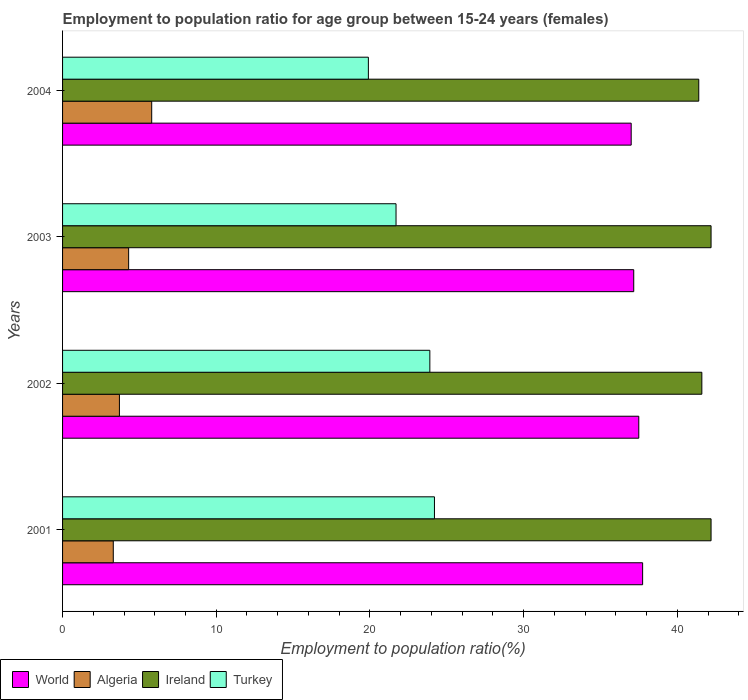How many different coloured bars are there?
Ensure brevity in your answer.  4. Are the number of bars per tick equal to the number of legend labels?
Ensure brevity in your answer.  Yes. How many bars are there on the 2nd tick from the top?
Make the answer very short. 4. What is the employment to population ratio in Ireland in 2004?
Make the answer very short. 41.4. Across all years, what is the maximum employment to population ratio in World?
Provide a short and direct response. 37.75. Across all years, what is the minimum employment to population ratio in World?
Make the answer very short. 37. What is the total employment to population ratio in Ireland in the graph?
Offer a very short reply. 167.4. What is the difference between the employment to population ratio in Turkey in 2002 and that in 2003?
Keep it short and to the point. 2.2. What is the difference between the employment to population ratio in Algeria in 2004 and the employment to population ratio in Ireland in 2002?
Your answer should be very brief. -35.8. What is the average employment to population ratio in Turkey per year?
Provide a short and direct response. 22.43. In the year 2003, what is the difference between the employment to population ratio in World and employment to population ratio in Ireland?
Make the answer very short. -5.03. What is the ratio of the employment to population ratio in Algeria in 2001 to that in 2002?
Your answer should be compact. 0.89. Is the employment to population ratio in Algeria in 2001 less than that in 2004?
Provide a short and direct response. Yes. What is the difference between the highest and the second highest employment to population ratio in World?
Your response must be concise. 0.25. What is the difference between the highest and the lowest employment to population ratio in Ireland?
Your answer should be compact. 0.8. In how many years, is the employment to population ratio in Ireland greater than the average employment to population ratio in Ireland taken over all years?
Make the answer very short. 2. What does the 4th bar from the bottom in 2003 represents?
Give a very brief answer. Turkey. How many bars are there?
Give a very brief answer. 16. What is the difference between two consecutive major ticks on the X-axis?
Provide a succinct answer. 10. Are the values on the major ticks of X-axis written in scientific E-notation?
Ensure brevity in your answer.  No. Does the graph contain any zero values?
Make the answer very short. No. Where does the legend appear in the graph?
Offer a terse response. Bottom left. How are the legend labels stacked?
Your response must be concise. Horizontal. What is the title of the graph?
Offer a very short reply. Employment to population ratio for age group between 15-24 years (females). What is the label or title of the X-axis?
Ensure brevity in your answer.  Employment to population ratio(%). What is the Employment to population ratio(%) in World in 2001?
Offer a terse response. 37.75. What is the Employment to population ratio(%) of Algeria in 2001?
Make the answer very short. 3.3. What is the Employment to population ratio(%) of Ireland in 2001?
Your answer should be compact. 42.2. What is the Employment to population ratio(%) in Turkey in 2001?
Ensure brevity in your answer.  24.2. What is the Employment to population ratio(%) in World in 2002?
Keep it short and to the point. 37.5. What is the Employment to population ratio(%) of Algeria in 2002?
Provide a succinct answer. 3.7. What is the Employment to population ratio(%) in Ireland in 2002?
Give a very brief answer. 41.6. What is the Employment to population ratio(%) in Turkey in 2002?
Ensure brevity in your answer.  23.9. What is the Employment to population ratio(%) in World in 2003?
Offer a very short reply. 37.17. What is the Employment to population ratio(%) of Algeria in 2003?
Your answer should be very brief. 4.3. What is the Employment to population ratio(%) of Ireland in 2003?
Offer a terse response. 42.2. What is the Employment to population ratio(%) of Turkey in 2003?
Offer a terse response. 21.7. What is the Employment to population ratio(%) in World in 2004?
Your response must be concise. 37. What is the Employment to population ratio(%) of Algeria in 2004?
Your answer should be compact. 5.8. What is the Employment to population ratio(%) in Ireland in 2004?
Give a very brief answer. 41.4. What is the Employment to population ratio(%) of Turkey in 2004?
Ensure brevity in your answer.  19.9. Across all years, what is the maximum Employment to population ratio(%) in World?
Keep it short and to the point. 37.75. Across all years, what is the maximum Employment to population ratio(%) in Algeria?
Offer a terse response. 5.8. Across all years, what is the maximum Employment to population ratio(%) of Ireland?
Your response must be concise. 42.2. Across all years, what is the maximum Employment to population ratio(%) of Turkey?
Your answer should be compact. 24.2. Across all years, what is the minimum Employment to population ratio(%) of World?
Ensure brevity in your answer.  37. Across all years, what is the minimum Employment to population ratio(%) in Algeria?
Offer a very short reply. 3.3. Across all years, what is the minimum Employment to population ratio(%) of Ireland?
Make the answer very short. 41.4. Across all years, what is the minimum Employment to population ratio(%) of Turkey?
Provide a short and direct response. 19.9. What is the total Employment to population ratio(%) of World in the graph?
Provide a succinct answer. 149.41. What is the total Employment to population ratio(%) of Ireland in the graph?
Provide a succinct answer. 167.4. What is the total Employment to population ratio(%) of Turkey in the graph?
Provide a short and direct response. 89.7. What is the difference between the Employment to population ratio(%) of World in 2001 and that in 2002?
Your answer should be very brief. 0.25. What is the difference between the Employment to population ratio(%) in Algeria in 2001 and that in 2002?
Ensure brevity in your answer.  -0.4. What is the difference between the Employment to population ratio(%) of Turkey in 2001 and that in 2002?
Give a very brief answer. 0.3. What is the difference between the Employment to population ratio(%) of World in 2001 and that in 2003?
Provide a succinct answer. 0.58. What is the difference between the Employment to population ratio(%) of World in 2001 and that in 2004?
Provide a short and direct response. 0.74. What is the difference between the Employment to population ratio(%) in Algeria in 2001 and that in 2004?
Offer a very short reply. -2.5. What is the difference between the Employment to population ratio(%) of Ireland in 2001 and that in 2004?
Your response must be concise. 0.8. What is the difference between the Employment to population ratio(%) in World in 2002 and that in 2003?
Offer a very short reply. 0.33. What is the difference between the Employment to population ratio(%) in Algeria in 2002 and that in 2003?
Your answer should be compact. -0.6. What is the difference between the Employment to population ratio(%) in Ireland in 2002 and that in 2003?
Offer a terse response. -0.6. What is the difference between the Employment to population ratio(%) of Turkey in 2002 and that in 2003?
Offer a terse response. 2.2. What is the difference between the Employment to population ratio(%) in World in 2002 and that in 2004?
Make the answer very short. 0.49. What is the difference between the Employment to population ratio(%) of Algeria in 2002 and that in 2004?
Your answer should be compact. -2.1. What is the difference between the Employment to population ratio(%) of Ireland in 2002 and that in 2004?
Provide a short and direct response. 0.2. What is the difference between the Employment to population ratio(%) of Turkey in 2002 and that in 2004?
Your answer should be very brief. 4. What is the difference between the Employment to population ratio(%) in World in 2003 and that in 2004?
Your response must be concise. 0.17. What is the difference between the Employment to population ratio(%) of World in 2001 and the Employment to population ratio(%) of Algeria in 2002?
Offer a terse response. 34.05. What is the difference between the Employment to population ratio(%) of World in 2001 and the Employment to population ratio(%) of Ireland in 2002?
Your response must be concise. -3.85. What is the difference between the Employment to population ratio(%) of World in 2001 and the Employment to population ratio(%) of Turkey in 2002?
Offer a very short reply. 13.85. What is the difference between the Employment to population ratio(%) of Algeria in 2001 and the Employment to population ratio(%) of Ireland in 2002?
Make the answer very short. -38.3. What is the difference between the Employment to population ratio(%) in Algeria in 2001 and the Employment to population ratio(%) in Turkey in 2002?
Ensure brevity in your answer.  -20.6. What is the difference between the Employment to population ratio(%) of Ireland in 2001 and the Employment to population ratio(%) of Turkey in 2002?
Your answer should be compact. 18.3. What is the difference between the Employment to population ratio(%) in World in 2001 and the Employment to population ratio(%) in Algeria in 2003?
Your answer should be very brief. 33.45. What is the difference between the Employment to population ratio(%) in World in 2001 and the Employment to population ratio(%) in Ireland in 2003?
Your response must be concise. -4.45. What is the difference between the Employment to population ratio(%) in World in 2001 and the Employment to population ratio(%) in Turkey in 2003?
Make the answer very short. 16.05. What is the difference between the Employment to population ratio(%) in Algeria in 2001 and the Employment to population ratio(%) in Ireland in 2003?
Keep it short and to the point. -38.9. What is the difference between the Employment to population ratio(%) of Algeria in 2001 and the Employment to population ratio(%) of Turkey in 2003?
Your answer should be compact. -18.4. What is the difference between the Employment to population ratio(%) of World in 2001 and the Employment to population ratio(%) of Algeria in 2004?
Offer a very short reply. 31.95. What is the difference between the Employment to population ratio(%) of World in 2001 and the Employment to population ratio(%) of Ireland in 2004?
Provide a short and direct response. -3.65. What is the difference between the Employment to population ratio(%) in World in 2001 and the Employment to population ratio(%) in Turkey in 2004?
Your response must be concise. 17.85. What is the difference between the Employment to population ratio(%) in Algeria in 2001 and the Employment to population ratio(%) in Ireland in 2004?
Your response must be concise. -38.1. What is the difference between the Employment to population ratio(%) in Algeria in 2001 and the Employment to population ratio(%) in Turkey in 2004?
Your answer should be compact. -16.6. What is the difference between the Employment to population ratio(%) in Ireland in 2001 and the Employment to population ratio(%) in Turkey in 2004?
Offer a terse response. 22.3. What is the difference between the Employment to population ratio(%) in World in 2002 and the Employment to population ratio(%) in Algeria in 2003?
Provide a short and direct response. 33.2. What is the difference between the Employment to population ratio(%) in World in 2002 and the Employment to population ratio(%) in Ireland in 2003?
Ensure brevity in your answer.  -4.7. What is the difference between the Employment to population ratio(%) in World in 2002 and the Employment to population ratio(%) in Turkey in 2003?
Your answer should be compact. 15.8. What is the difference between the Employment to population ratio(%) in Algeria in 2002 and the Employment to population ratio(%) in Ireland in 2003?
Offer a very short reply. -38.5. What is the difference between the Employment to population ratio(%) in Ireland in 2002 and the Employment to population ratio(%) in Turkey in 2003?
Provide a succinct answer. 19.9. What is the difference between the Employment to population ratio(%) of World in 2002 and the Employment to population ratio(%) of Algeria in 2004?
Provide a short and direct response. 31.7. What is the difference between the Employment to population ratio(%) in World in 2002 and the Employment to population ratio(%) in Ireland in 2004?
Your response must be concise. -3.9. What is the difference between the Employment to population ratio(%) of World in 2002 and the Employment to population ratio(%) of Turkey in 2004?
Offer a terse response. 17.6. What is the difference between the Employment to population ratio(%) in Algeria in 2002 and the Employment to population ratio(%) in Ireland in 2004?
Make the answer very short. -37.7. What is the difference between the Employment to population ratio(%) of Algeria in 2002 and the Employment to population ratio(%) of Turkey in 2004?
Offer a very short reply. -16.2. What is the difference between the Employment to population ratio(%) in Ireland in 2002 and the Employment to population ratio(%) in Turkey in 2004?
Your answer should be very brief. 21.7. What is the difference between the Employment to population ratio(%) of World in 2003 and the Employment to population ratio(%) of Algeria in 2004?
Make the answer very short. 31.37. What is the difference between the Employment to population ratio(%) in World in 2003 and the Employment to population ratio(%) in Ireland in 2004?
Provide a short and direct response. -4.23. What is the difference between the Employment to population ratio(%) of World in 2003 and the Employment to population ratio(%) of Turkey in 2004?
Provide a succinct answer. 17.27. What is the difference between the Employment to population ratio(%) in Algeria in 2003 and the Employment to population ratio(%) in Ireland in 2004?
Ensure brevity in your answer.  -37.1. What is the difference between the Employment to population ratio(%) of Algeria in 2003 and the Employment to population ratio(%) of Turkey in 2004?
Your answer should be compact. -15.6. What is the difference between the Employment to population ratio(%) in Ireland in 2003 and the Employment to population ratio(%) in Turkey in 2004?
Your response must be concise. 22.3. What is the average Employment to population ratio(%) in World per year?
Provide a succinct answer. 37.35. What is the average Employment to population ratio(%) of Algeria per year?
Your answer should be very brief. 4.28. What is the average Employment to population ratio(%) in Ireland per year?
Provide a short and direct response. 41.85. What is the average Employment to population ratio(%) of Turkey per year?
Ensure brevity in your answer.  22.43. In the year 2001, what is the difference between the Employment to population ratio(%) of World and Employment to population ratio(%) of Algeria?
Give a very brief answer. 34.45. In the year 2001, what is the difference between the Employment to population ratio(%) in World and Employment to population ratio(%) in Ireland?
Give a very brief answer. -4.45. In the year 2001, what is the difference between the Employment to population ratio(%) in World and Employment to population ratio(%) in Turkey?
Give a very brief answer. 13.55. In the year 2001, what is the difference between the Employment to population ratio(%) of Algeria and Employment to population ratio(%) of Ireland?
Give a very brief answer. -38.9. In the year 2001, what is the difference between the Employment to population ratio(%) of Algeria and Employment to population ratio(%) of Turkey?
Provide a succinct answer. -20.9. In the year 2001, what is the difference between the Employment to population ratio(%) of Ireland and Employment to population ratio(%) of Turkey?
Provide a succinct answer. 18. In the year 2002, what is the difference between the Employment to population ratio(%) in World and Employment to population ratio(%) in Algeria?
Offer a very short reply. 33.8. In the year 2002, what is the difference between the Employment to population ratio(%) in World and Employment to population ratio(%) in Ireland?
Your answer should be very brief. -4.1. In the year 2002, what is the difference between the Employment to population ratio(%) of World and Employment to population ratio(%) of Turkey?
Provide a short and direct response. 13.6. In the year 2002, what is the difference between the Employment to population ratio(%) in Algeria and Employment to population ratio(%) in Ireland?
Ensure brevity in your answer.  -37.9. In the year 2002, what is the difference between the Employment to population ratio(%) in Algeria and Employment to population ratio(%) in Turkey?
Give a very brief answer. -20.2. In the year 2002, what is the difference between the Employment to population ratio(%) of Ireland and Employment to population ratio(%) of Turkey?
Keep it short and to the point. 17.7. In the year 2003, what is the difference between the Employment to population ratio(%) in World and Employment to population ratio(%) in Algeria?
Give a very brief answer. 32.87. In the year 2003, what is the difference between the Employment to population ratio(%) in World and Employment to population ratio(%) in Ireland?
Offer a terse response. -5.03. In the year 2003, what is the difference between the Employment to population ratio(%) in World and Employment to population ratio(%) in Turkey?
Offer a very short reply. 15.47. In the year 2003, what is the difference between the Employment to population ratio(%) of Algeria and Employment to population ratio(%) of Ireland?
Offer a very short reply. -37.9. In the year 2003, what is the difference between the Employment to population ratio(%) in Algeria and Employment to population ratio(%) in Turkey?
Keep it short and to the point. -17.4. In the year 2004, what is the difference between the Employment to population ratio(%) of World and Employment to population ratio(%) of Algeria?
Keep it short and to the point. 31.2. In the year 2004, what is the difference between the Employment to population ratio(%) in World and Employment to population ratio(%) in Ireland?
Keep it short and to the point. -4.4. In the year 2004, what is the difference between the Employment to population ratio(%) in World and Employment to population ratio(%) in Turkey?
Provide a succinct answer. 17.1. In the year 2004, what is the difference between the Employment to population ratio(%) in Algeria and Employment to population ratio(%) in Ireland?
Your answer should be very brief. -35.6. In the year 2004, what is the difference between the Employment to population ratio(%) in Algeria and Employment to population ratio(%) in Turkey?
Your answer should be very brief. -14.1. What is the ratio of the Employment to population ratio(%) in World in 2001 to that in 2002?
Keep it short and to the point. 1.01. What is the ratio of the Employment to population ratio(%) in Algeria in 2001 to that in 2002?
Give a very brief answer. 0.89. What is the ratio of the Employment to population ratio(%) in Ireland in 2001 to that in 2002?
Ensure brevity in your answer.  1.01. What is the ratio of the Employment to population ratio(%) of Turkey in 2001 to that in 2002?
Your answer should be compact. 1.01. What is the ratio of the Employment to population ratio(%) of World in 2001 to that in 2003?
Provide a short and direct response. 1.02. What is the ratio of the Employment to population ratio(%) in Algeria in 2001 to that in 2003?
Provide a short and direct response. 0.77. What is the ratio of the Employment to population ratio(%) in Ireland in 2001 to that in 2003?
Make the answer very short. 1. What is the ratio of the Employment to population ratio(%) in Turkey in 2001 to that in 2003?
Provide a short and direct response. 1.12. What is the ratio of the Employment to population ratio(%) in World in 2001 to that in 2004?
Give a very brief answer. 1.02. What is the ratio of the Employment to population ratio(%) in Algeria in 2001 to that in 2004?
Offer a terse response. 0.57. What is the ratio of the Employment to population ratio(%) of Ireland in 2001 to that in 2004?
Make the answer very short. 1.02. What is the ratio of the Employment to population ratio(%) of Turkey in 2001 to that in 2004?
Make the answer very short. 1.22. What is the ratio of the Employment to population ratio(%) in World in 2002 to that in 2003?
Your response must be concise. 1.01. What is the ratio of the Employment to population ratio(%) of Algeria in 2002 to that in 2003?
Your answer should be very brief. 0.86. What is the ratio of the Employment to population ratio(%) in Ireland in 2002 to that in 2003?
Keep it short and to the point. 0.99. What is the ratio of the Employment to population ratio(%) in Turkey in 2002 to that in 2003?
Your answer should be very brief. 1.1. What is the ratio of the Employment to population ratio(%) in World in 2002 to that in 2004?
Keep it short and to the point. 1.01. What is the ratio of the Employment to population ratio(%) in Algeria in 2002 to that in 2004?
Your answer should be very brief. 0.64. What is the ratio of the Employment to population ratio(%) in Ireland in 2002 to that in 2004?
Your answer should be very brief. 1. What is the ratio of the Employment to population ratio(%) of Turkey in 2002 to that in 2004?
Ensure brevity in your answer.  1.2. What is the ratio of the Employment to population ratio(%) of Algeria in 2003 to that in 2004?
Keep it short and to the point. 0.74. What is the ratio of the Employment to population ratio(%) in Ireland in 2003 to that in 2004?
Keep it short and to the point. 1.02. What is the ratio of the Employment to population ratio(%) of Turkey in 2003 to that in 2004?
Provide a succinct answer. 1.09. What is the difference between the highest and the second highest Employment to population ratio(%) in World?
Provide a short and direct response. 0.25. What is the difference between the highest and the second highest Employment to population ratio(%) of Algeria?
Keep it short and to the point. 1.5. What is the difference between the highest and the second highest Employment to population ratio(%) in Ireland?
Offer a very short reply. 0. What is the difference between the highest and the lowest Employment to population ratio(%) of World?
Your answer should be very brief. 0.74. What is the difference between the highest and the lowest Employment to population ratio(%) of Turkey?
Make the answer very short. 4.3. 